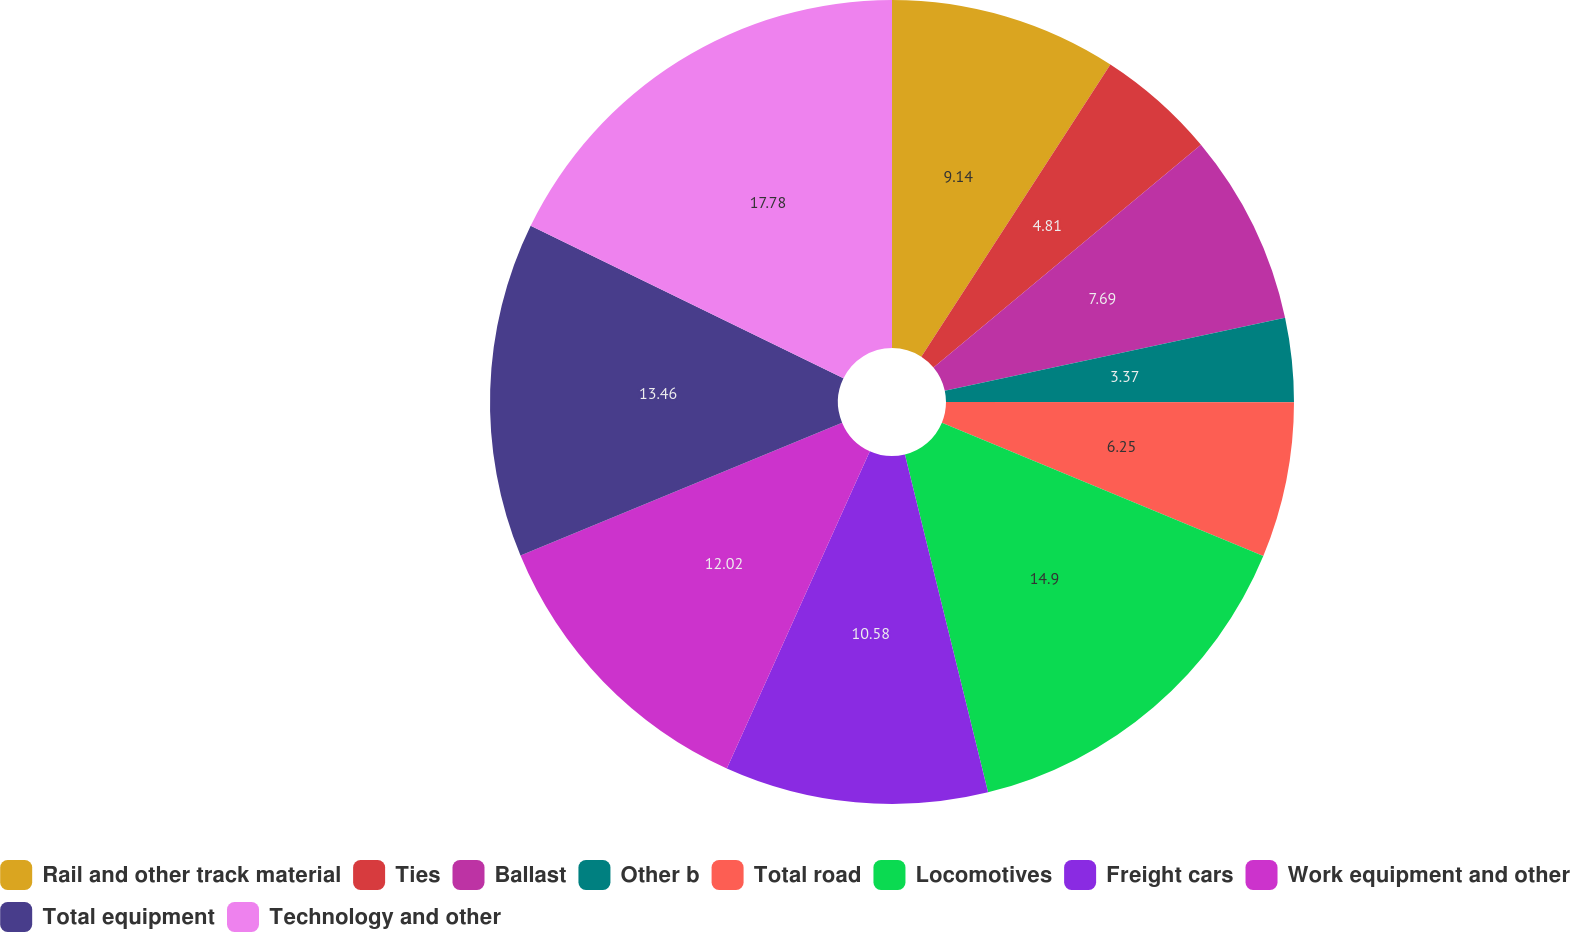Convert chart. <chart><loc_0><loc_0><loc_500><loc_500><pie_chart><fcel>Rail and other track material<fcel>Ties<fcel>Ballast<fcel>Other b<fcel>Total road<fcel>Locomotives<fcel>Freight cars<fcel>Work equipment and other<fcel>Total equipment<fcel>Technology and other<nl><fcel>9.14%<fcel>4.81%<fcel>7.69%<fcel>3.37%<fcel>6.25%<fcel>14.9%<fcel>10.58%<fcel>12.02%<fcel>13.46%<fcel>17.78%<nl></chart> 